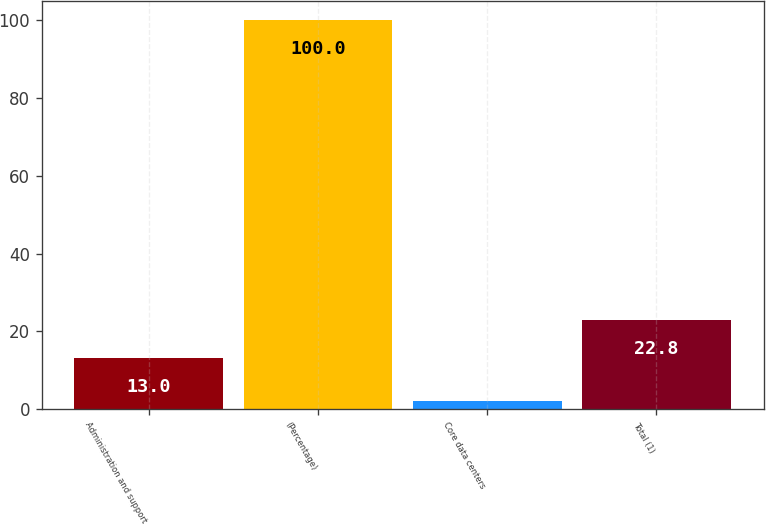<chart> <loc_0><loc_0><loc_500><loc_500><bar_chart><fcel>Administration and support<fcel>(Percentage)<fcel>Core data centers<fcel>Total (1)<nl><fcel>13<fcel>100<fcel>2<fcel>22.8<nl></chart> 